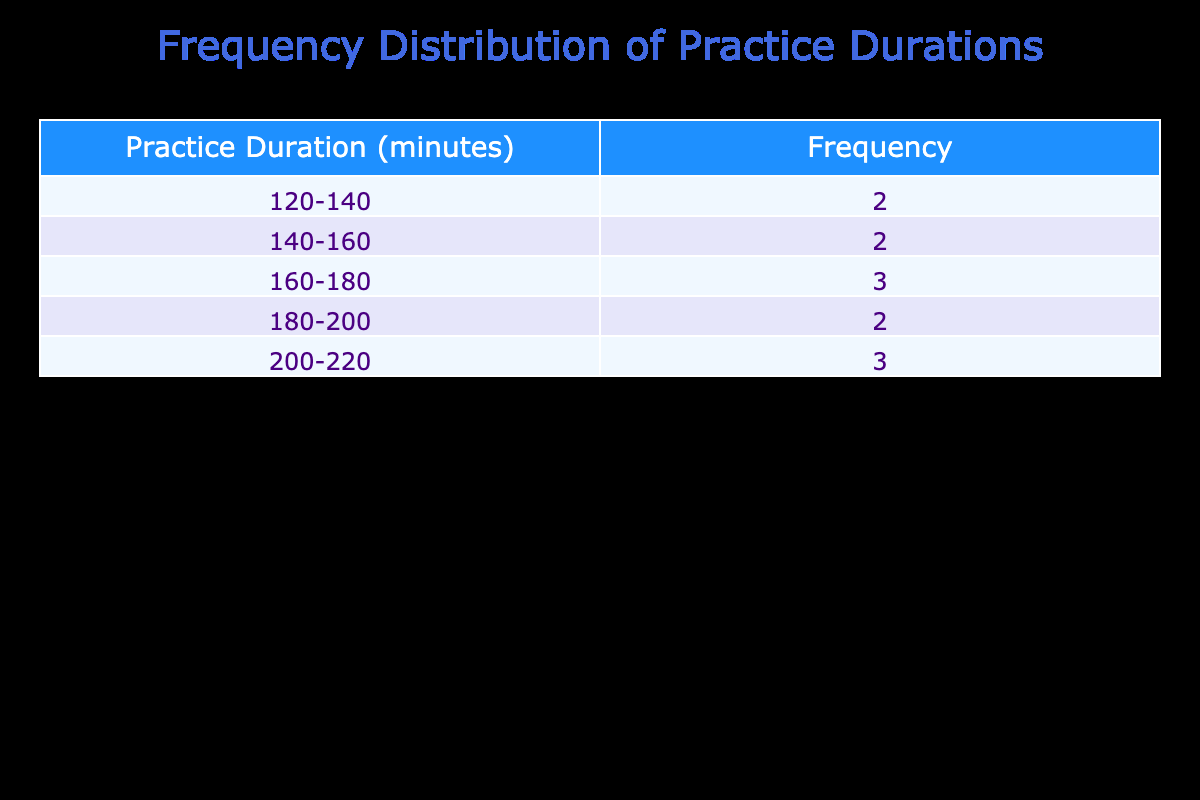What is the frequency of practice durations between 120 and 140 minutes? From the frequency distribution table, we see that the range of 120-140 minutes corresponds to a frequency of 3. This means there are 3 months where practice durations fall within this interval.
Answer: 3 What is the longest practice duration recorded in the table? By looking at the durations listed, the maximum is 220 minutes, which occurs in July.
Answer: 220 minutes Are there more months with practice durations between 160 and 180 minutes compared to months with durations between 180 and 200 minutes? The frequency for 160-180 minutes is 3 (February, May, November), while the frequency for 180-200 minutes is 3 (March, April, August). Thus, both ranges have equal occurrences, which means the answer is no.
Answer: No What is the average practice duration for the months listed? The total practice duration is calculated as 120 + 150 + 180 + 200 + 160 + 140 + 220 + 190 + 175 + 210 + 160 + 130 = 1,825 minutes. There are 12 months, so the average is 1,825 / 12 = 152.08 minutes.
Answer: 152.08 minutes Is the practice duration in June less than the average practice duration? The practice duration in June is 140 minutes. The average practice duration we calculated is 152.08 minutes. Since 140 minutes is less than the average 152.08, the answer is yes.
Answer: Yes How many months have practice durations that exceed 180 minutes? The months with practice durations exceeding 180 minutes are: April (200), July (220), August (190), and October (210). Counting these gives us four months.
Answer: 4 What is the combined frequency of practice durations between 140 and 160 minutes? The frequency for the range of 140-160 minutes is 3 (June, November) and for 160-180 minutes is 3 (February, May, November). Combined, this is 3 + 3 = 6.
Answer: 6 Which month had the highest practice duration, and what was the duration? The month of July had the highest practice duration at 220 minutes. This is found directly in the table, confirming it is the maximum value.
Answer: July, 220 minutes If December's duration was increased by 30 minutes, would it then fall into the 160-180 minutes range? December's duration is currently 130 minutes. Increasing it by 30 gives us 160 minutes, which is the lower limit of the range 160-180. Therefore, it would fall within this new range.
Answer: Yes 